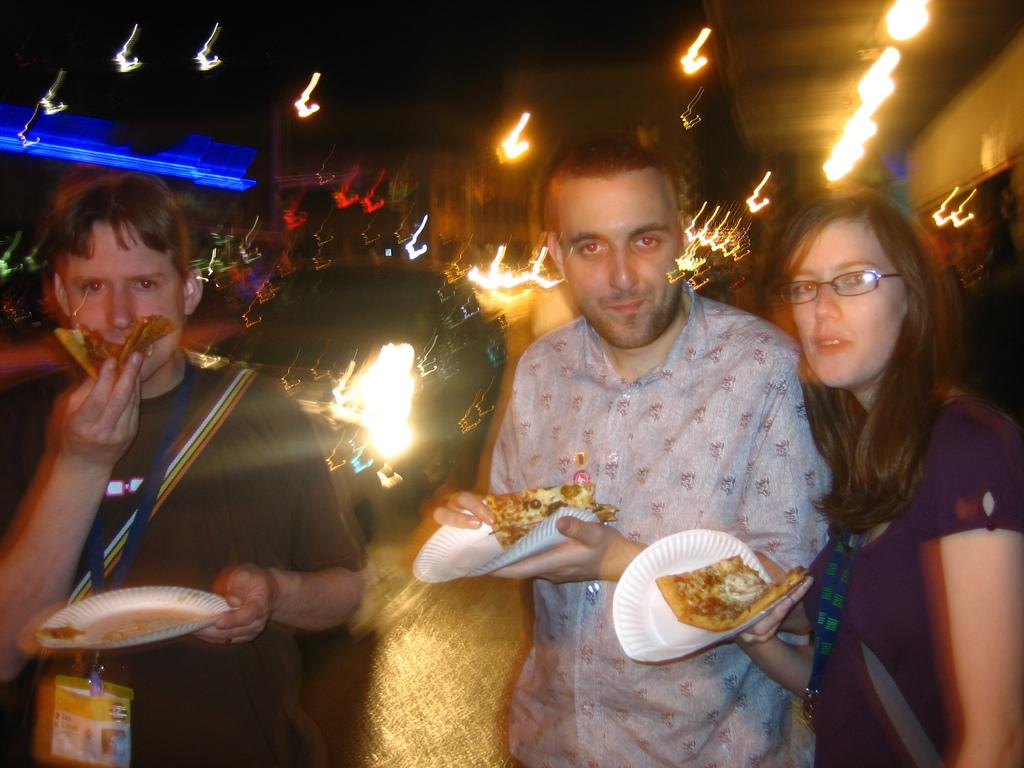How many people are in the image? There are people in the image, but the exact number is not specified. What are the people doing in the image? The people are standing and holding a food item on a plastic plate. Is one of the people eating the food item? Yes, one of the people is eating. Can you describe the background of the image? The background of the image is blurred. How many ants can be seen crawling on the food item in the image? There is no mention of ants in the image, so we cannot determine their presence or number. What type of drop can be seen falling from the sky in the image? There is no mention of a drop falling from the sky in the image, so we cannot determine its presence or type. 